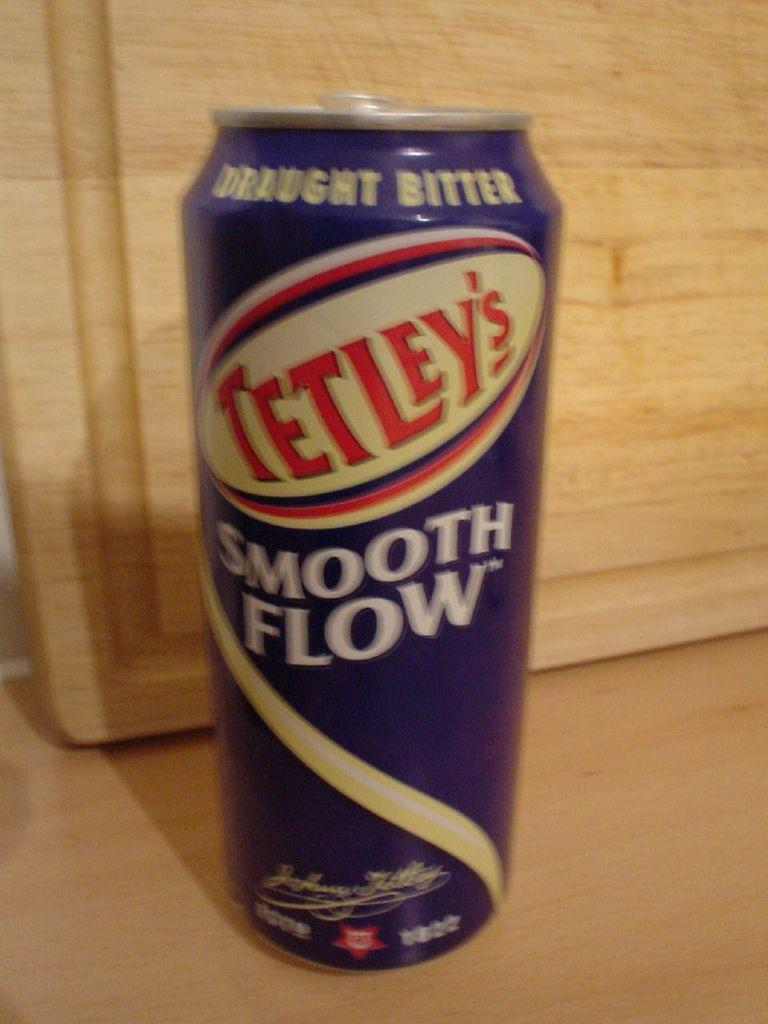<image>
Summarize the visual content of the image. Tetley's Smooth Flow is described as draught bitter. 